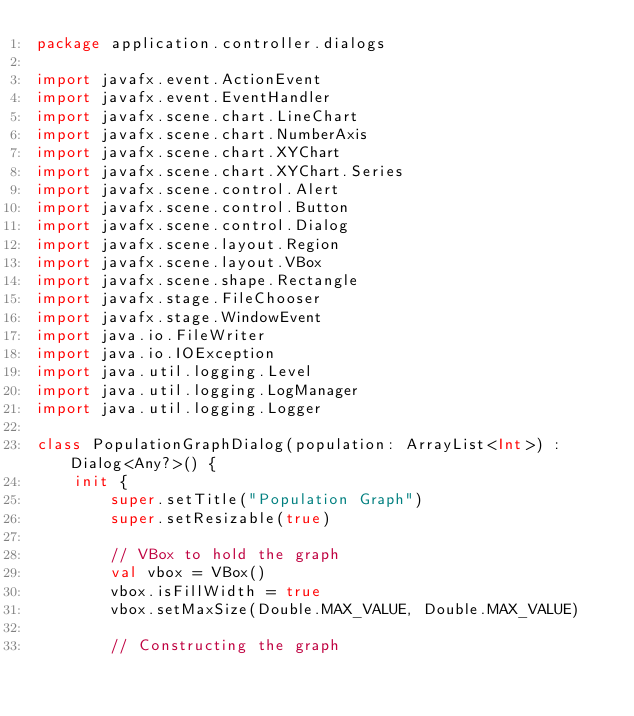Convert code to text. <code><loc_0><loc_0><loc_500><loc_500><_Kotlin_>package application.controller.dialogs

import javafx.event.ActionEvent
import javafx.event.EventHandler
import javafx.scene.chart.LineChart
import javafx.scene.chart.NumberAxis
import javafx.scene.chart.XYChart
import javafx.scene.chart.XYChart.Series
import javafx.scene.control.Alert
import javafx.scene.control.Button
import javafx.scene.control.Dialog
import javafx.scene.layout.Region
import javafx.scene.layout.VBox
import javafx.scene.shape.Rectangle
import javafx.stage.FileChooser
import javafx.stage.WindowEvent
import java.io.FileWriter
import java.io.IOException
import java.util.logging.Level
import java.util.logging.LogManager
import java.util.logging.Logger

class PopulationGraphDialog(population: ArrayList<Int>) : Dialog<Any?>() {
    init {
        super.setTitle("Population Graph")
        super.setResizable(true)

        // VBox to hold the graph
        val vbox = VBox()
        vbox.isFillWidth = true
        vbox.setMaxSize(Double.MAX_VALUE, Double.MAX_VALUE)

        // Constructing the graph</code> 